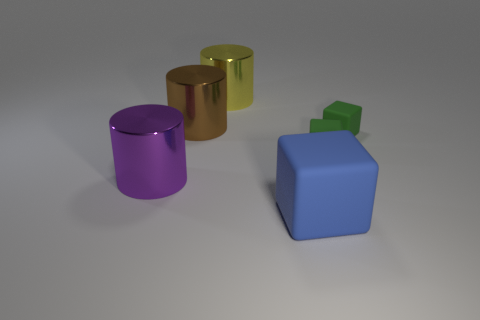Add 3 cubes. How many objects exist? 9 Add 6 metal objects. How many metal objects are left? 9 Add 4 small rubber blocks. How many small rubber blocks exist? 6 Subtract 0 cyan cylinders. How many objects are left? 6 Subtract all big yellow metal cylinders. Subtract all green matte objects. How many objects are left? 3 